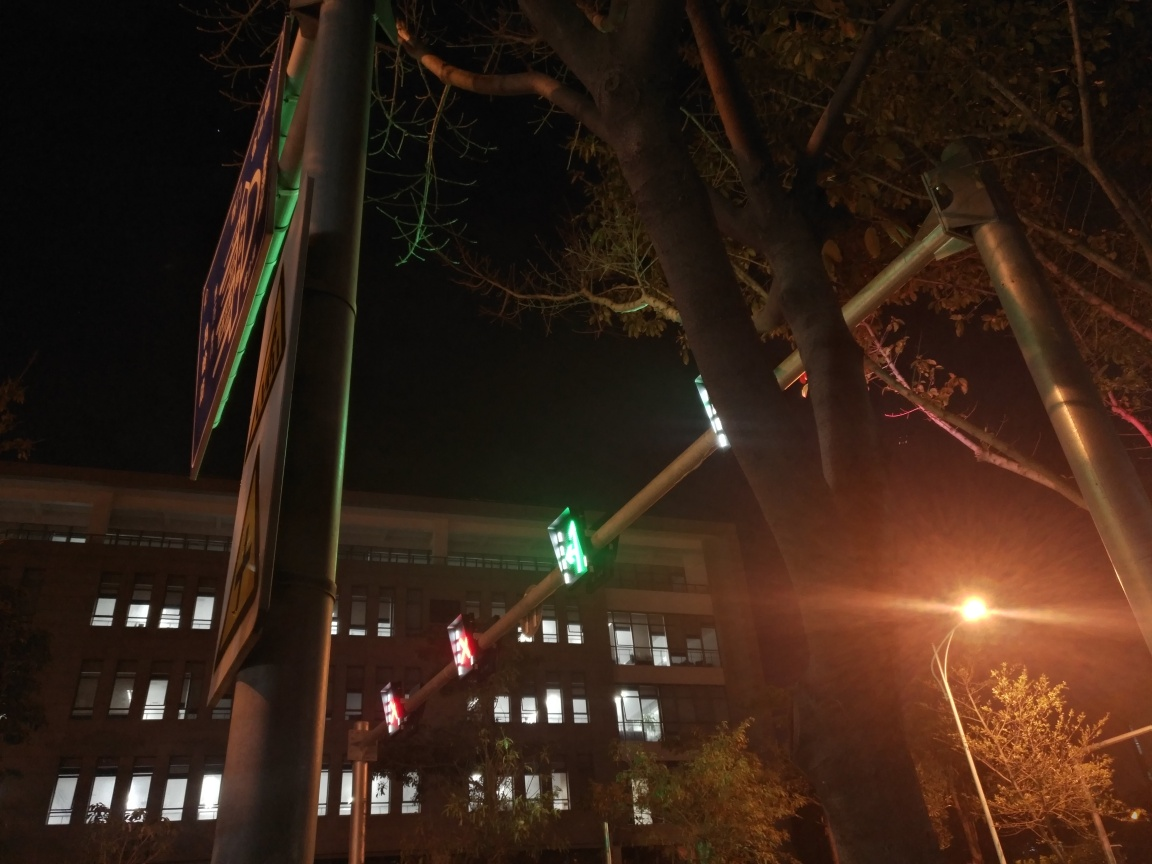What might be the implications of the streetlight's glow in terms of photography? The glow from the streetlight creates a flare effect in the photograph, which can add an atmospheric or dreamy quality to the scene. It could be intentional to create mood, or it might be seen as an obstruction to capturing clear details in the rest of the photograph. How could a photographer avoid or leverage this light flare? To avoid light flare, photographers might use a lens hood or change their angle relative to the light source. To leverage it, they could use the flare to draw attention to specific elements in the scene or to enhance the visual storytelling by creating a certain ambiance. 